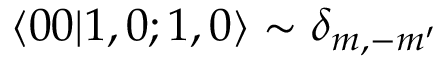<formula> <loc_0><loc_0><loc_500><loc_500>\langle 0 0 | 1 , 0 ; 1 , 0 \rangle \sim \delta _ { m , - m ^ { \prime } }</formula> 